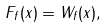Convert formula to latex. <formula><loc_0><loc_0><loc_500><loc_500>F _ { f } ( x ) = \| W _ { f } ( x ) \| ,</formula> 